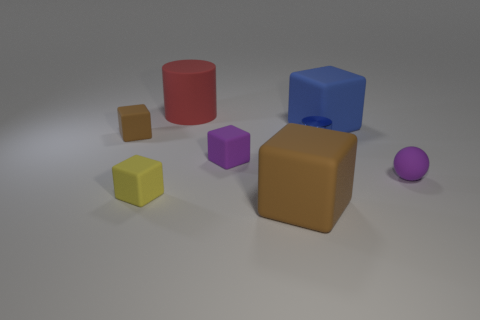How many big objects are the same shape as the small metallic thing?
Make the answer very short. 1. How many blue things are either big matte things or matte objects?
Your response must be concise. 1. The small object that is behind the small purple cube and on the right side of the tiny brown block is made of what material?
Your answer should be very brief. Metal. Is the material of the large red thing the same as the purple block?
Keep it short and to the point. Yes. What number of cubes have the same size as the metallic thing?
Keep it short and to the point. 3. Are there the same number of small cubes that are to the right of the small brown rubber object and brown cubes?
Ensure brevity in your answer.  Yes. How many rubber things are in front of the large red thing and left of the purple cube?
Provide a succinct answer. 2. There is a brown rubber thing on the right side of the small brown rubber block; is it the same shape as the big blue thing?
Your answer should be very brief. Yes. There is a cylinder that is the same size as the ball; what is it made of?
Keep it short and to the point. Metal. Are there an equal number of brown matte objects in front of the tiny matte ball and cubes that are in front of the tiny blue shiny cylinder?
Keep it short and to the point. No. 